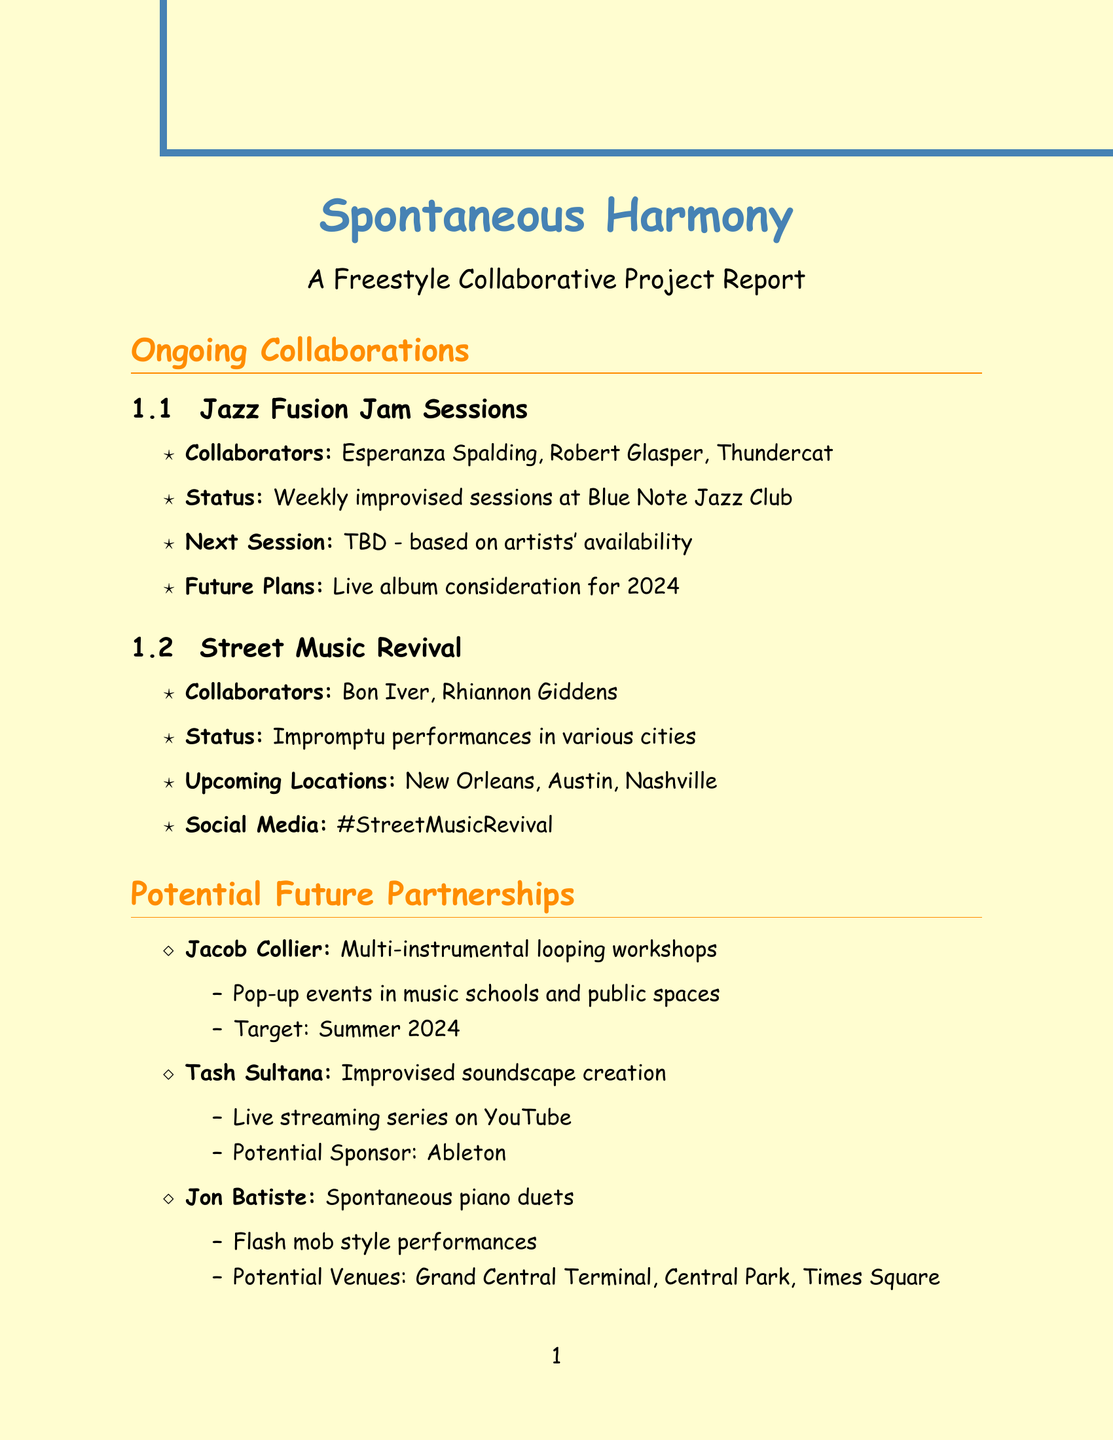what is the status of the Jazz Fusion Jam Sessions? The status provided notes that these sessions are weekly improvised sessions at the Blue Note Jazz Club.
Answer: Weekly improvised sessions at Blue Note Jazz Club who are the collaborators for the Street Music Revival project? The collaborators for this project are listed as Bon Iver and Rhiannon Giddens.
Answer: Bon Iver, Rhiannon Giddens what potential recording is being considered for the Jazz Fusion Jam Sessions? The document mentions a live album consideration for 2024.
Answer: Live album consideration for 2024 when is the Montreux Jazz Festival scheduled? The date for the Montreux Jazz Festival is given as July 2024.
Answer: July 2024 what is the proposed format for Jacob Collier's project idea? The proposed format for Jacob Collier's workshops is described as pop-up events.
Answer: Pop-up events in music schools and public spaces what are two potential venues for Jon Batiste's spontaneous duets? The potential venues listed include Grand Central Terminal and Times Square.
Answer: Grand Central Terminal, Times Square what is a primary purpose of the portable PA system mentioned in equipment needs? The purpose noted for the portable PA system is for impromptu street performances.
Answer: Impromptu street performances which social media platforms are suggested for the social media strategy? The platforms mentioned include Instagram, TikTok, and YouTube.
Answer: Instagram, TikTok, YouTube what hashtag is associated with the Street Music Revival? The document points out the hashtag related to Street Music Revival as #StreetMusicRevival.
Answer: #StreetMusicRevival 